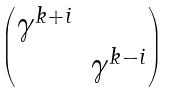<formula> <loc_0><loc_0><loc_500><loc_500>\begin{pmatrix} \gamma ^ { k + i } & \\ & \gamma ^ { k - i } \\ \end{pmatrix}</formula> 